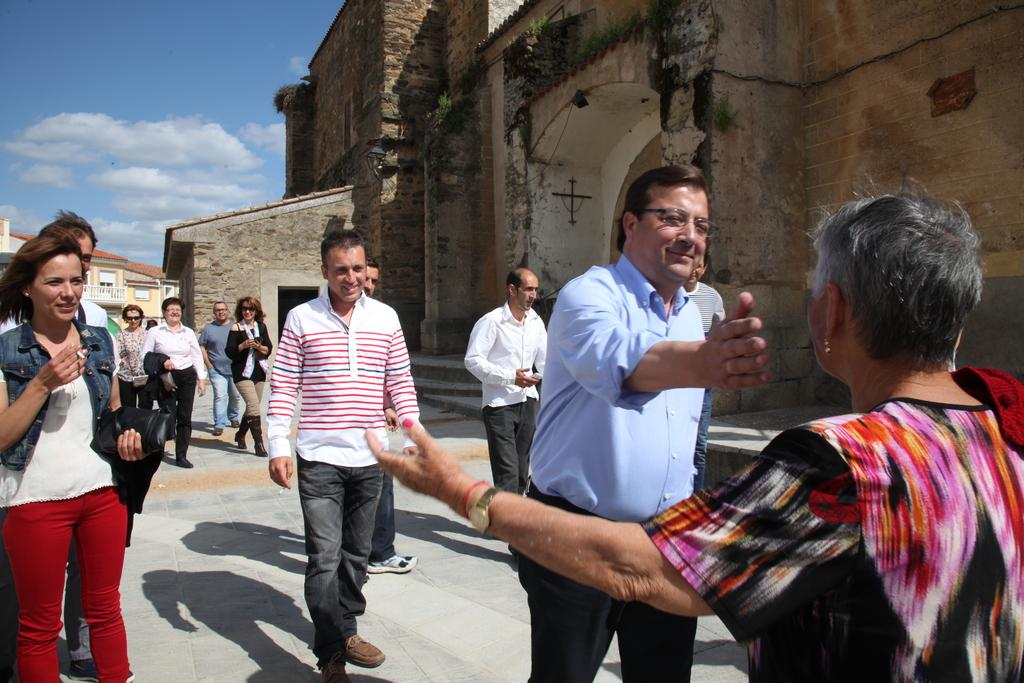What are the people in the image doing? The people in the image are standing and walking on the road. What can be seen in the background of the image? There are buildings and the sky visible in the background of the image. What type of bed can be seen in the image? There is no bed present in the image; it features people standing and walking on the road with buildings and the sky in the background. 